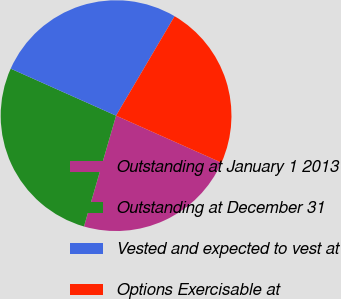<chart> <loc_0><loc_0><loc_500><loc_500><pie_chart><fcel>Outstanding at January 1 2013<fcel>Outstanding at December 31<fcel>Vested and expected to vest at<fcel>Options Exercisable at<nl><fcel>22.81%<fcel>27.19%<fcel>26.79%<fcel>23.21%<nl></chart> 